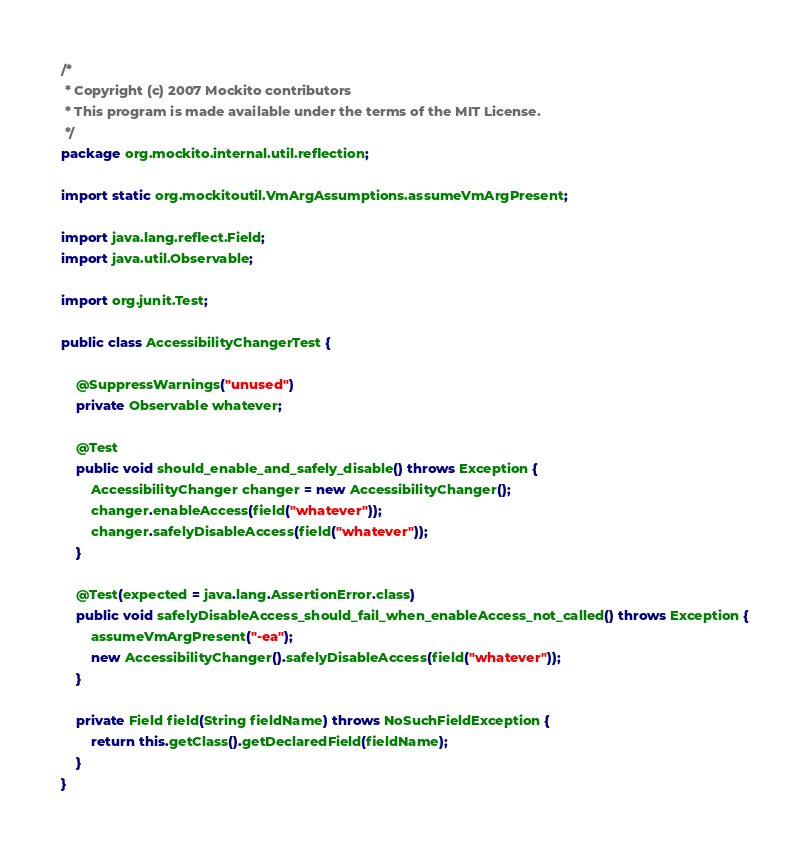Convert code to text. <code><loc_0><loc_0><loc_500><loc_500><_Java_>/*
 * Copyright (c) 2007 Mockito contributors
 * This program is made available under the terms of the MIT License.
 */
package org.mockito.internal.util.reflection;

import static org.mockitoutil.VmArgAssumptions.assumeVmArgPresent;

import java.lang.reflect.Field;
import java.util.Observable;

import org.junit.Test;

public class AccessibilityChangerTest {

    @SuppressWarnings("unused")
    private Observable whatever;

    @Test
    public void should_enable_and_safely_disable() throws Exception {
        AccessibilityChanger changer = new AccessibilityChanger();
        changer.enableAccess(field("whatever"));
        changer.safelyDisableAccess(field("whatever"));
    }

    @Test(expected = java.lang.AssertionError.class)
    public void safelyDisableAccess_should_fail_when_enableAccess_not_called() throws Exception {
        assumeVmArgPresent("-ea");
        new AccessibilityChanger().safelyDisableAccess(field("whatever"));
    }

    private Field field(String fieldName) throws NoSuchFieldException {
        return this.getClass().getDeclaredField(fieldName);
    }
}
</code> 